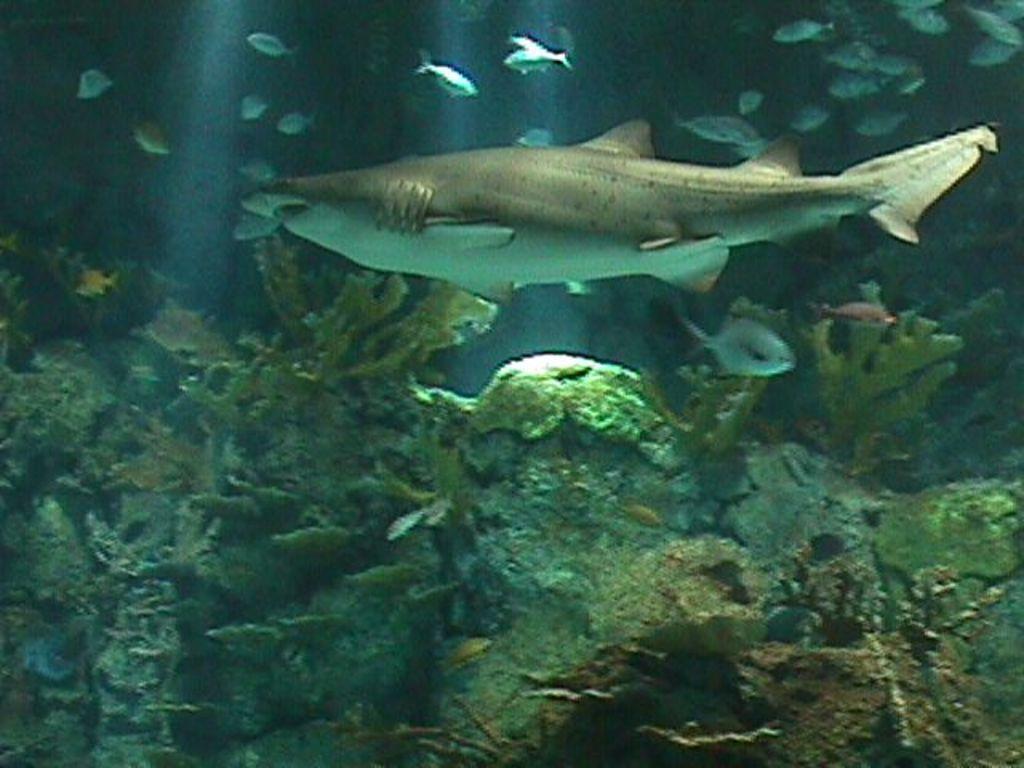How would you summarize this image in a sentence or two? In this image I can see fishes in the water. There are plants at the bottom. 